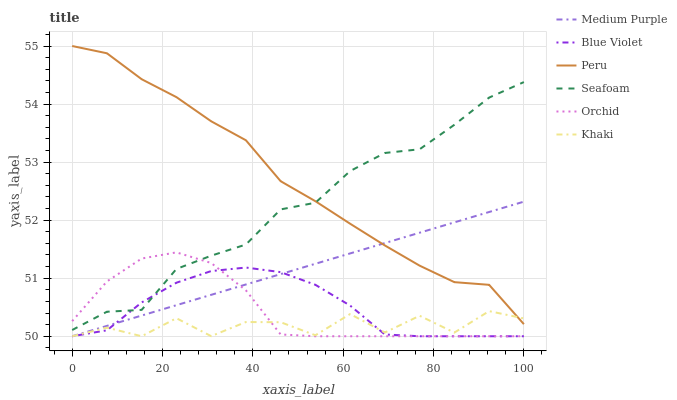Does Khaki have the minimum area under the curve?
Answer yes or no. Yes. Does Peru have the maximum area under the curve?
Answer yes or no. Yes. Does Seafoam have the minimum area under the curve?
Answer yes or no. No. Does Seafoam have the maximum area under the curve?
Answer yes or no. No. Is Medium Purple the smoothest?
Answer yes or no. Yes. Is Khaki the roughest?
Answer yes or no. Yes. Is Seafoam the smoothest?
Answer yes or no. No. Is Seafoam the roughest?
Answer yes or no. No. Does Khaki have the lowest value?
Answer yes or no. Yes. Does Seafoam have the lowest value?
Answer yes or no. No. Does Peru have the highest value?
Answer yes or no. Yes. Does Seafoam have the highest value?
Answer yes or no. No. Is Orchid less than Peru?
Answer yes or no. Yes. Is Peru greater than Orchid?
Answer yes or no. Yes. Does Peru intersect Medium Purple?
Answer yes or no. Yes. Is Peru less than Medium Purple?
Answer yes or no. No. Is Peru greater than Medium Purple?
Answer yes or no. No. Does Orchid intersect Peru?
Answer yes or no. No. 